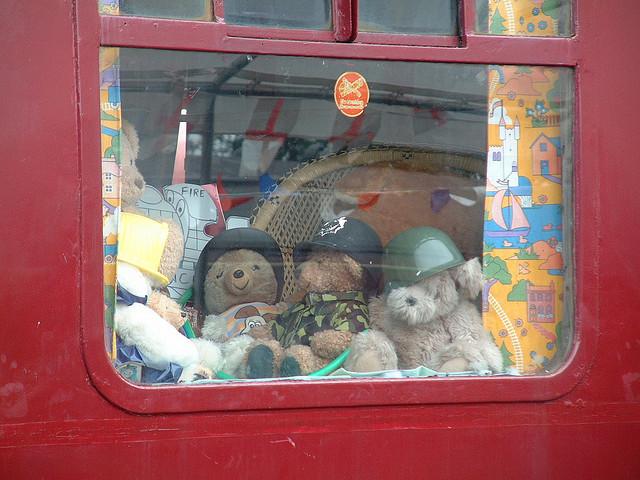Are all of the bears wearing a hat?
Short answer required. Yes. Is it raining outside of this window?
Concise answer only. No. What pattern is on the shirt of the bear in the middle?
Be succinct. Camouflage. 